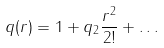<formula> <loc_0><loc_0><loc_500><loc_500>q ( r ) = 1 + q _ { 2 } \frac { r ^ { 2 } } { 2 ! } + \dots</formula> 